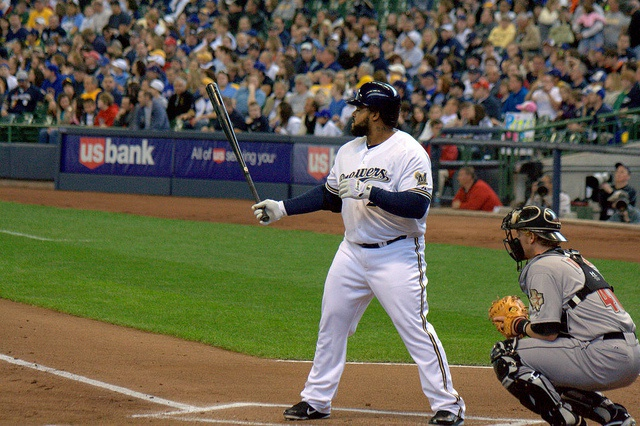Describe the objects in this image and their specific colors. I can see people in olive, black, and gray tones, people in olive, lavender, darkgray, and black tones, people in olive, black, darkgray, and gray tones, people in olive, maroon, brown, and black tones, and baseball bat in olive, black, gray, navy, and darkgreen tones in this image. 